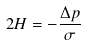<formula> <loc_0><loc_0><loc_500><loc_500>2 H = - \frac { \Delta p } \sigma</formula> 